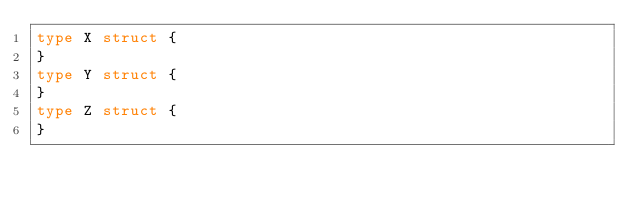<code> <loc_0><loc_0><loc_500><loc_500><_Go_>type X struct {
}
type Y struct {
}
type Z struct {
}
</code> 